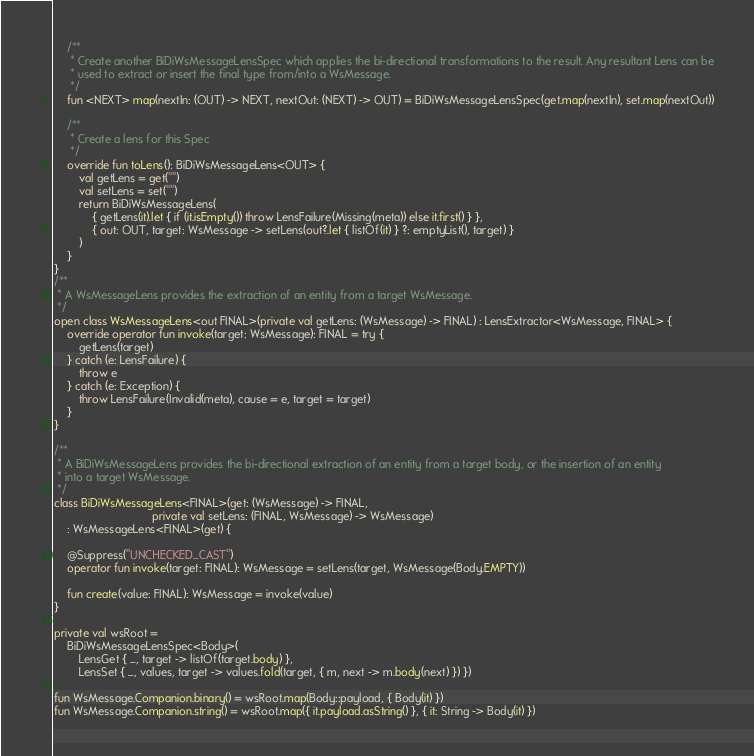Convert code to text. <code><loc_0><loc_0><loc_500><loc_500><_Kotlin_>    /**
     * Create another BiDiWsMessageLensSpec which applies the bi-directional transformations to the result. Any resultant Lens can be
     * used to extract or insert the final type from/into a WsMessage.
     */
    fun <NEXT> map(nextIn: (OUT) -> NEXT, nextOut: (NEXT) -> OUT) = BiDiWsMessageLensSpec(get.map(nextIn), set.map(nextOut))

    /**
     * Create a lens for this Spec
     */
    override fun toLens(): BiDiWsMessageLens<OUT> {
        val getLens = get("")
        val setLens = set("")
        return BiDiWsMessageLens(
            { getLens(it).let { if (it.isEmpty()) throw LensFailure(Missing(meta)) else it.first() } },
            { out: OUT, target: WsMessage -> setLens(out?.let { listOf(it) } ?: emptyList(), target) }
        )
    }
}
/**
 * A WsMessageLens provides the extraction of an entity from a target WsMessage.
 */
open class WsMessageLens<out FINAL>(private val getLens: (WsMessage) -> FINAL) : LensExtractor<WsMessage, FINAL> {
    override operator fun invoke(target: WsMessage): FINAL = try {
        getLens(target)
    } catch (e: LensFailure) {
        throw e
    } catch (e: Exception) {
        throw LensFailure(Invalid(meta), cause = e, target = target)
    }
}

/**
 * A BiDiWsMessageLens provides the bi-directional extraction of an entity from a target body, or the insertion of an entity
 * into a target WsMessage.
 */
class BiDiWsMessageLens<FINAL>(get: (WsMessage) -> FINAL,
                               private val setLens: (FINAL, WsMessage) -> WsMessage)
    : WsMessageLens<FINAL>(get) {

    @Suppress("UNCHECKED_CAST")
    operator fun invoke(target: FINAL): WsMessage = setLens(target, WsMessage(Body.EMPTY))

    fun create(value: FINAL): WsMessage = invoke(value)
}

private val wsRoot =
    BiDiWsMessageLensSpec<Body>(
        LensGet { _, target -> listOf(target.body) },
        LensSet { _, values, target -> values.fold(target, { m, next -> m.body(next) }) })

fun WsMessage.Companion.binary() = wsRoot.map(Body::payload, { Body(it) })
fun WsMessage.Companion.string() = wsRoot.map({ it.payload.asString() }, { it: String -> Body(it) })
</code> 